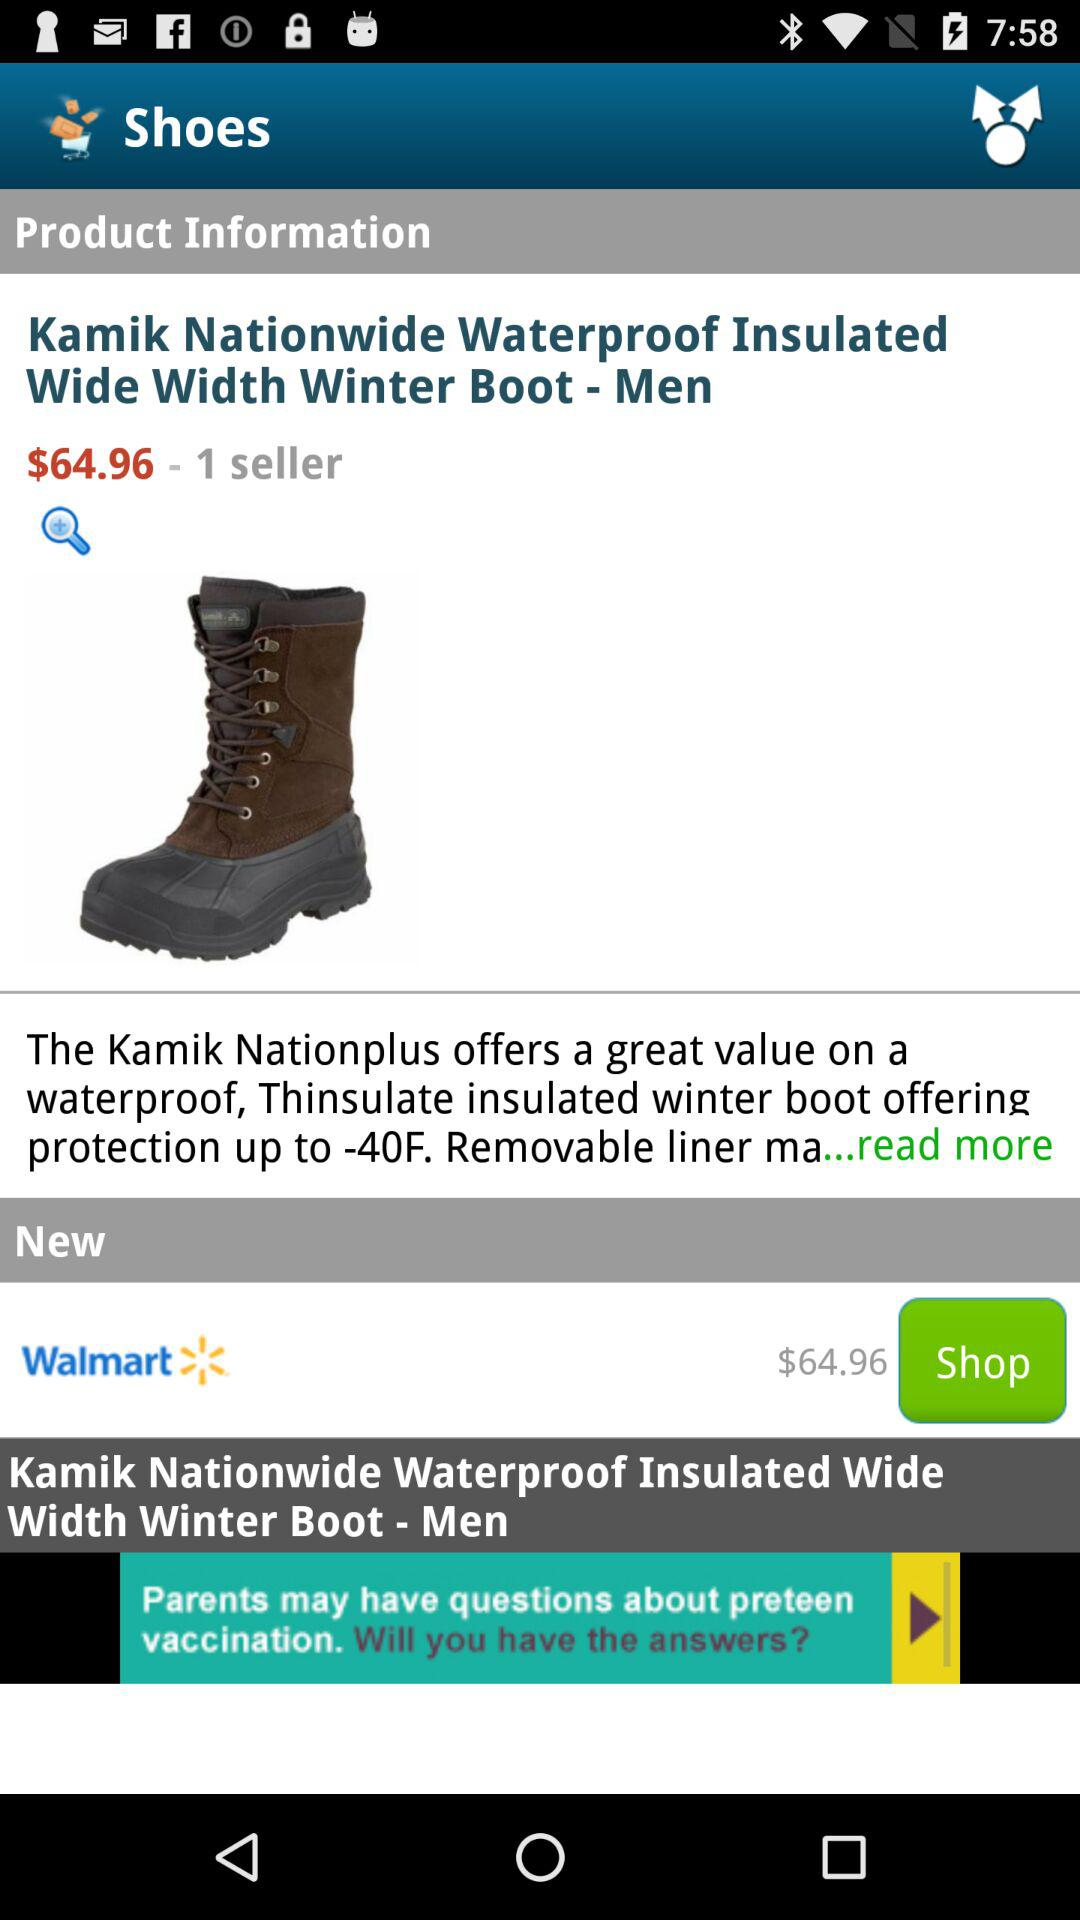What is the name of the seller?
When the provided information is insufficient, respond with <no answer>. <no answer> 